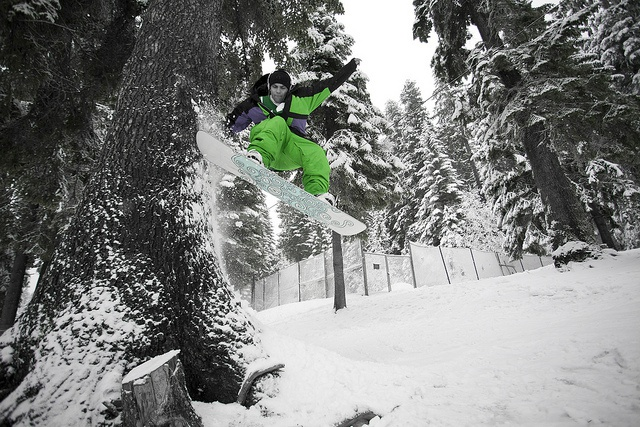Describe the objects in this image and their specific colors. I can see people in black, lightgreen, green, and gray tones and snowboard in black, darkgray, lightgray, gray, and lightblue tones in this image. 